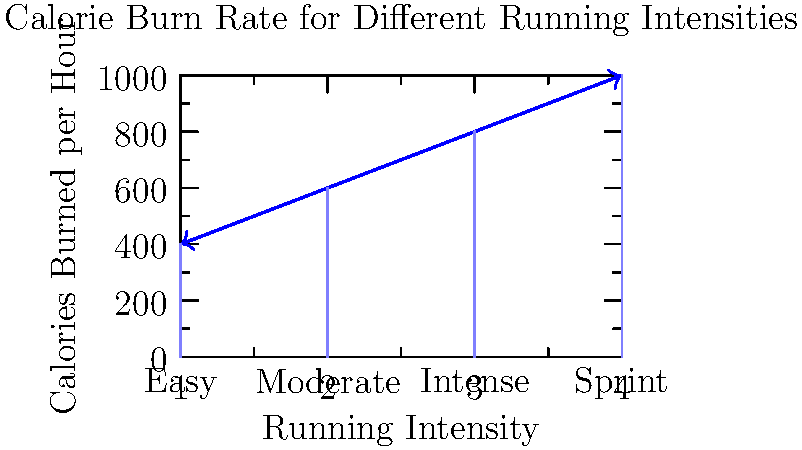As a marathon runner with diabetes, you're monitoring your calorie burn rate during training. The bar graph shows the calories burned per hour at different running intensities. If you run at a moderate intensity for 45 minutes and then sprint for 15 minutes, how many calories would you burn in total? Let's break this down step-by-step:

1. Identify the calorie burn rates from the graph:
   - Moderate intensity: 600 calories per hour
   - Sprint: 1000 calories per hour

2. Calculate calories burned during moderate intensity running:
   - Time spent: 45 minutes = 0.75 hours
   - Calories burned = 600 calories/hour × 0.75 hours
   - Calories burned = 450 calories

3. Calculate calories burned during sprinting:
   - Time spent: 15 minutes = 0.25 hours
   - Calories burned = 1000 calories/hour × 0.25 hours
   - Calories burned = 250 calories

4. Sum up the total calories burned:
   - Total calories = Moderate intensity calories + Sprint calories
   - Total calories = 450 calories + 250 calories
   - Total calories = 700 calories

Therefore, the total number of calories burned during the 1-hour workout is 700 calories.
Answer: 700 calories 